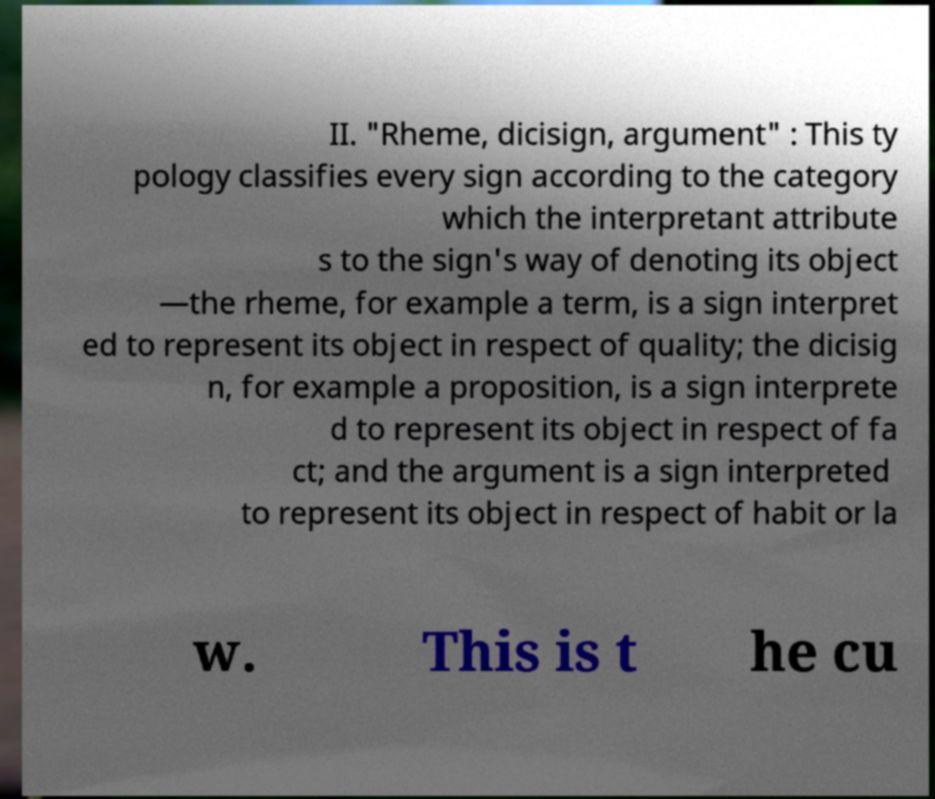Can you read and provide the text displayed in the image?This photo seems to have some interesting text. Can you extract and type it out for me? II. "Rheme, dicisign, argument" : This ty pology classifies every sign according to the category which the interpretant attribute s to the sign's way of denoting its object —the rheme, for example a term, is a sign interpret ed to represent its object in respect of quality; the dicisig n, for example a proposition, is a sign interprete d to represent its object in respect of fa ct; and the argument is a sign interpreted to represent its object in respect of habit or la w. This is t he cu 